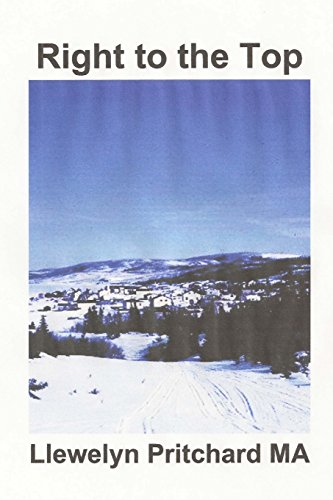What emotions do the cover portray, and how might they relate to the book's themes? The serene, wintry landscape conveys a sense of isolation and perhaps the harsh challenges the characters might face. It corresponds to themes of struggle and resilience in confronting corruption. 